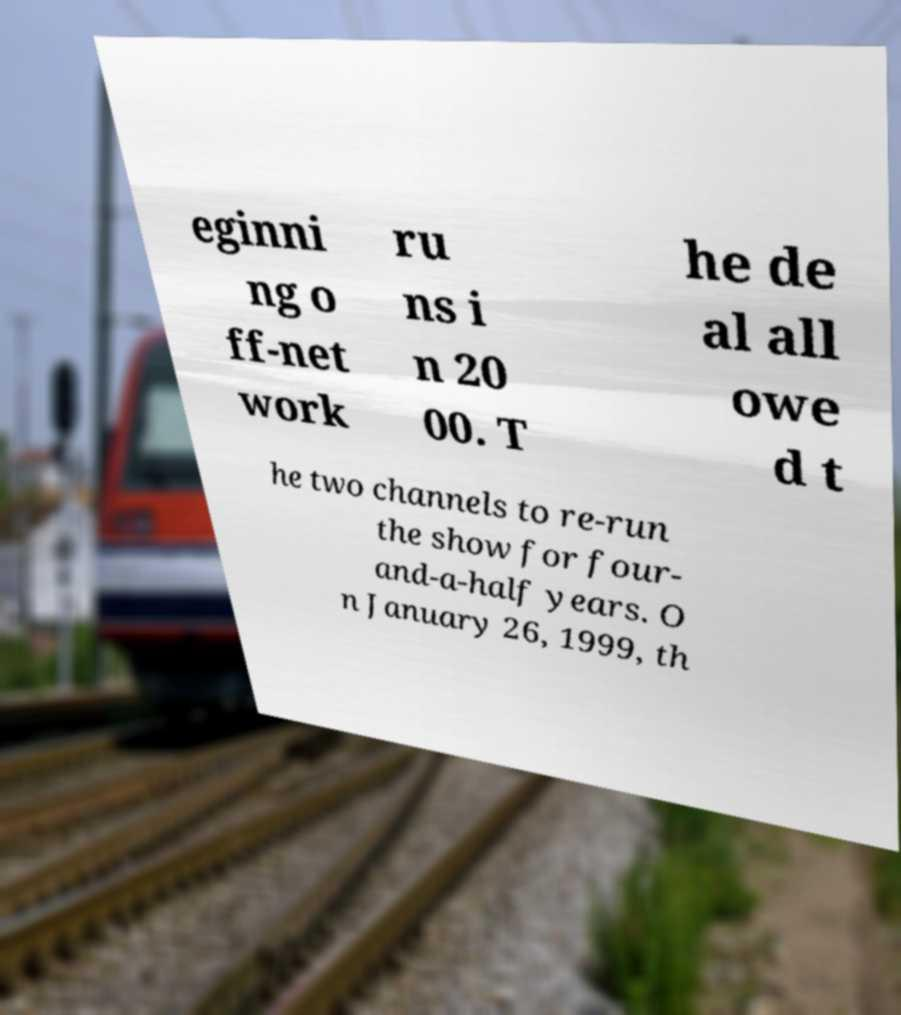Can you read and provide the text displayed in the image?This photo seems to have some interesting text. Can you extract and type it out for me? eginni ng o ff-net work ru ns i n 20 00. T he de al all owe d t he two channels to re-run the show for four- and-a-half years. O n January 26, 1999, th 